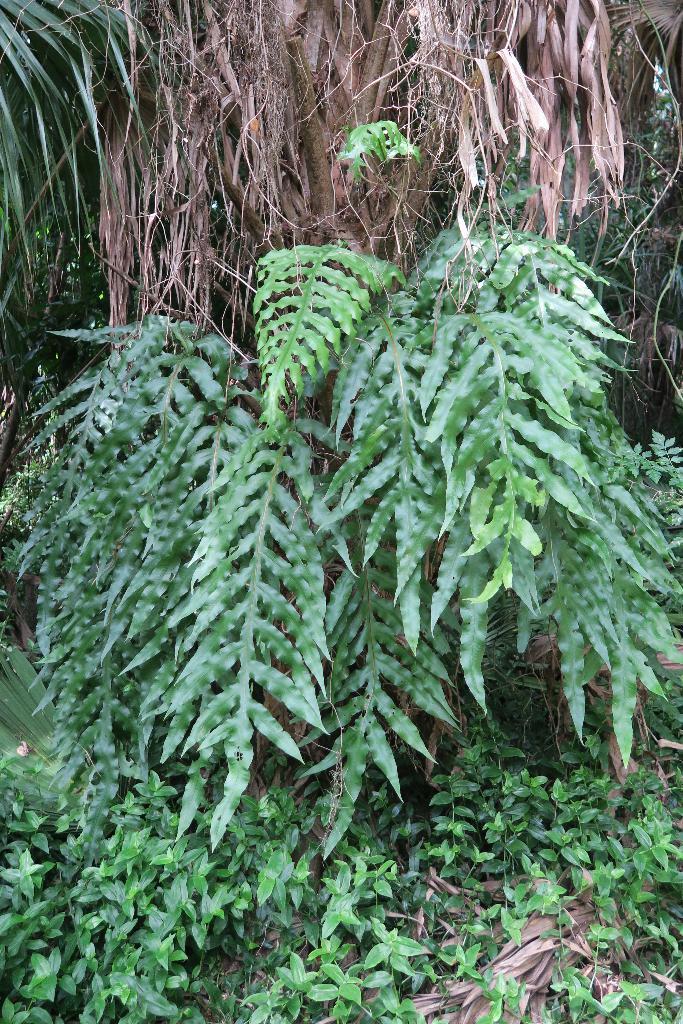Please provide a concise description of this image. In this picture we can observe some plants. There are some dried leaves in this picture. 